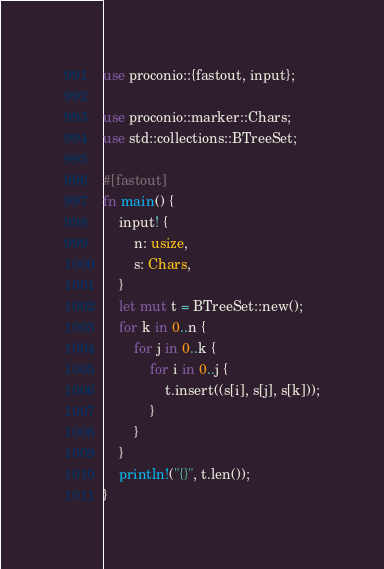<code> <loc_0><loc_0><loc_500><loc_500><_Rust_>use proconio::{fastout, input};

use proconio::marker::Chars;
use std::collections::BTreeSet;

#[fastout]
fn main() {
    input! {
        n: usize,
        s: Chars,
    }
    let mut t = BTreeSet::new();
    for k in 0..n {
        for j in 0..k {
            for i in 0..j {
                t.insert((s[i], s[j], s[k]));
            }
        }
    }
    println!("{}", t.len());
}
</code> 